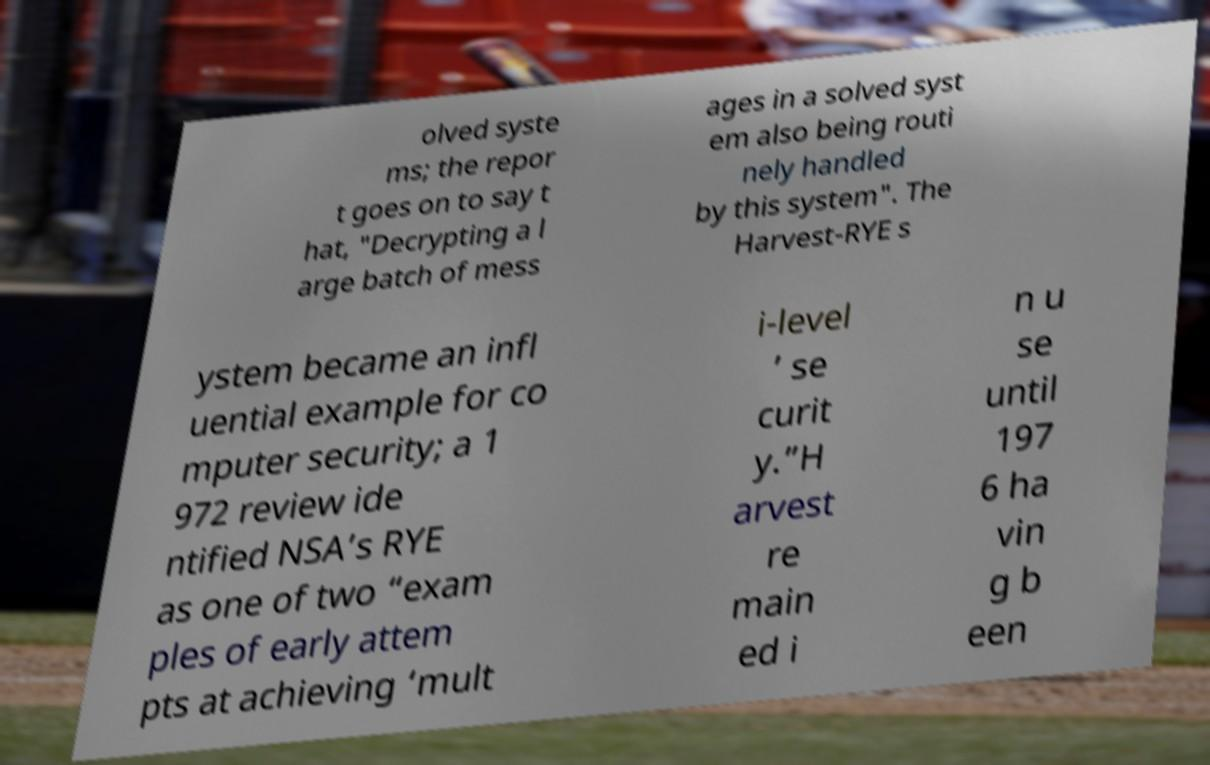What messages or text are displayed in this image? I need them in a readable, typed format. olved syste ms; the repor t goes on to say t hat, "Decrypting a l arge batch of mess ages in a solved syst em also being routi nely handled by this system". The Harvest-RYE s ystem became an infl uential example for co mputer security; a 1 972 review ide ntified NSA’s RYE as one of two “exam ples of early attem pts at achieving ‘mult i-level ’ se curit y.”H arvest re main ed i n u se until 197 6 ha vin g b een 